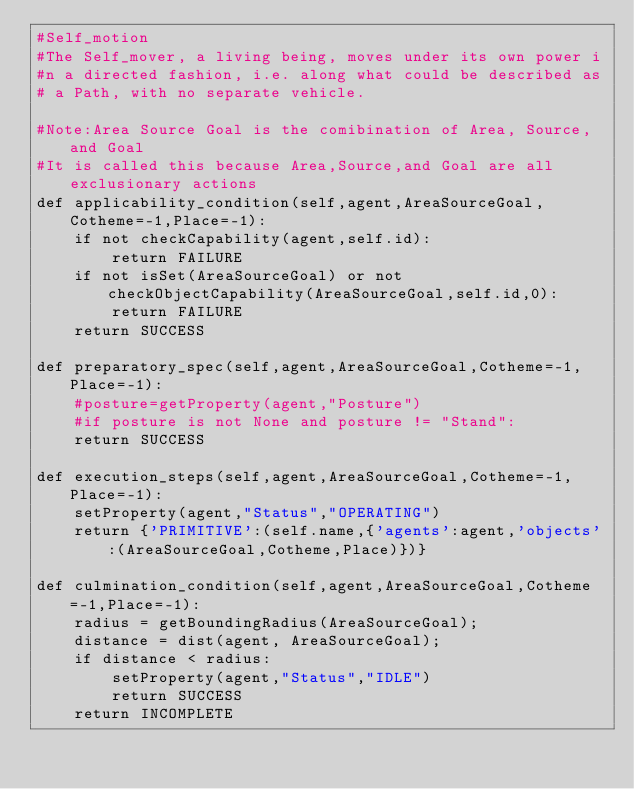Convert code to text. <code><loc_0><loc_0><loc_500><loc_500><_Python_>#Self_motion
#The Self_mover, a living being, moves under its own power i
#n a directed fashion, i.e. along what could be described as
# a Path, with no separate vehicle.

#Note:Area Source Goal is the comibination of Area, Source, and Goal
#It is called this because Area,Source,and Goal are all exclusionary actions
def applicability_condition(self,agent,AreaSourceGoal,Cotheme=-1,Place=-1):
	if not checkCapability(agent,self.id):
		return FAILURE
	if not isSet(AreaSourceGoal) or not checkObjectCapability(AreaSourceGoal,self.id,0):
		return FAILURE
	return SUCCESS

def preparatory_spec(self,agent,AreaSourceGoal,Cotheme=-1,Place=-1):
	#posture=getProperty(agent,"Posture")
	#if posture is not None and posture != "Stand":
	return SUCCESS

def execution_steps(self,agent,AreaSourceGoal,Cotheme=-1,Place=-1):
	setProperty(agent,"Status","OPERATING")
	return {'PRIMITIVE':(self.name,{'agents':agent,'objects':(AreaSourceGoal,Cotheme,Place)})}

def culmination_condition(self,agent,AreaSourceGoal,Cotheme=-1,Place=-1):
	radius = getBoundingRadius(AreaSourceGoal);
	distance = dist(agent, AreaSourceGoal);
	if distance < radius:
		setProperty(agent,"Status","IDLE")
		return SUCCESS
	return INCOMPLETE

</code> 